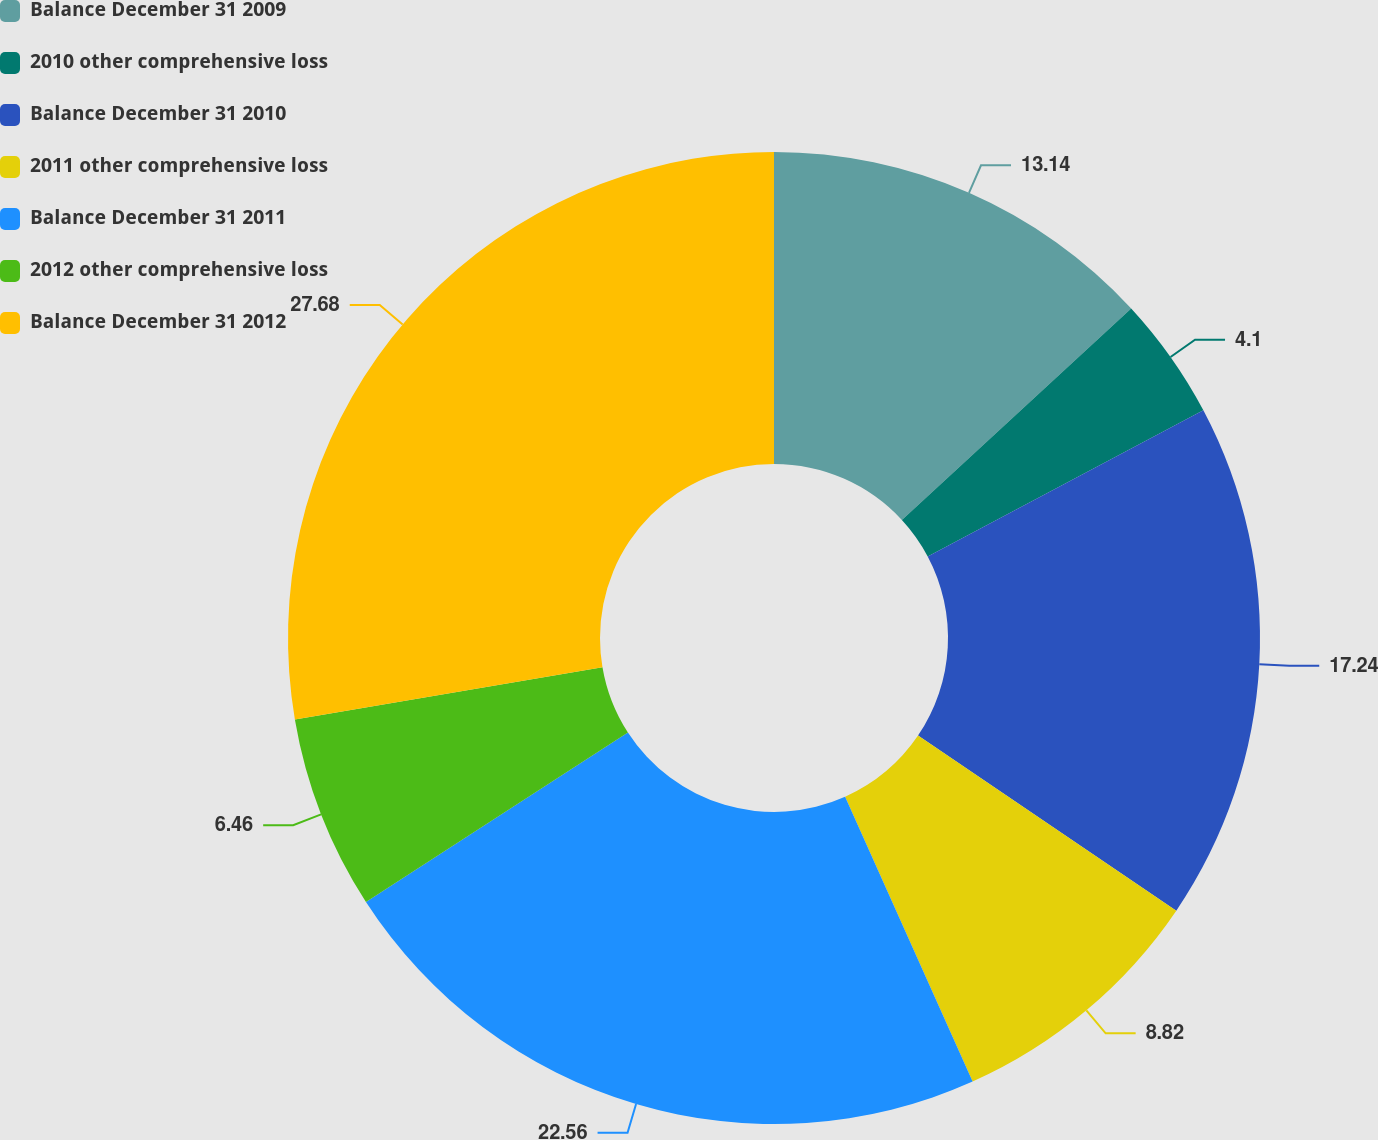Convert chart. <chart><loc_0><loc_0><loc_500><loc_500><pie_chart><fcel>Balance December 31 2009<fcel>2010 other comprehensive loss<fcel>Balance December 31 2010<fcel>2011 other comprehensive loss<fcel>Balance December 31 2011<fcel>2012 other comprehensive loss<fcel>Balance December 31 2012<nl><fcel>13.14%<fcel>4.1%<fcel>17.24%<fcel>8.82%<fcel>22.56%<fcel>6.46%<fcel>27.68%<nl></chart> 